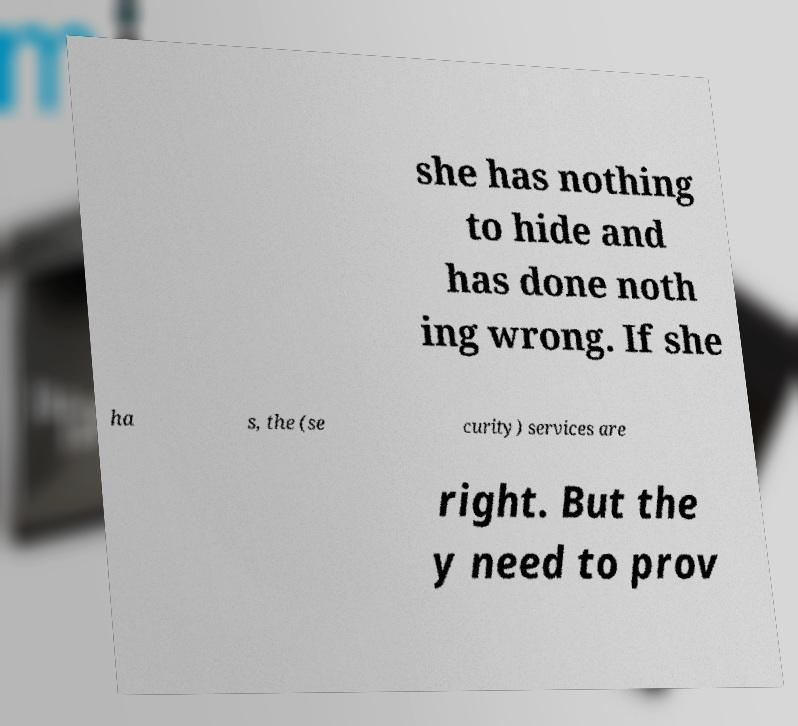For documentation purposes, I need the text within this image transcribed. Could you provide that? she has nothing to hide and has done noth ing wrong. If she ha s, the (se curity) services are right. But the y need to prov 